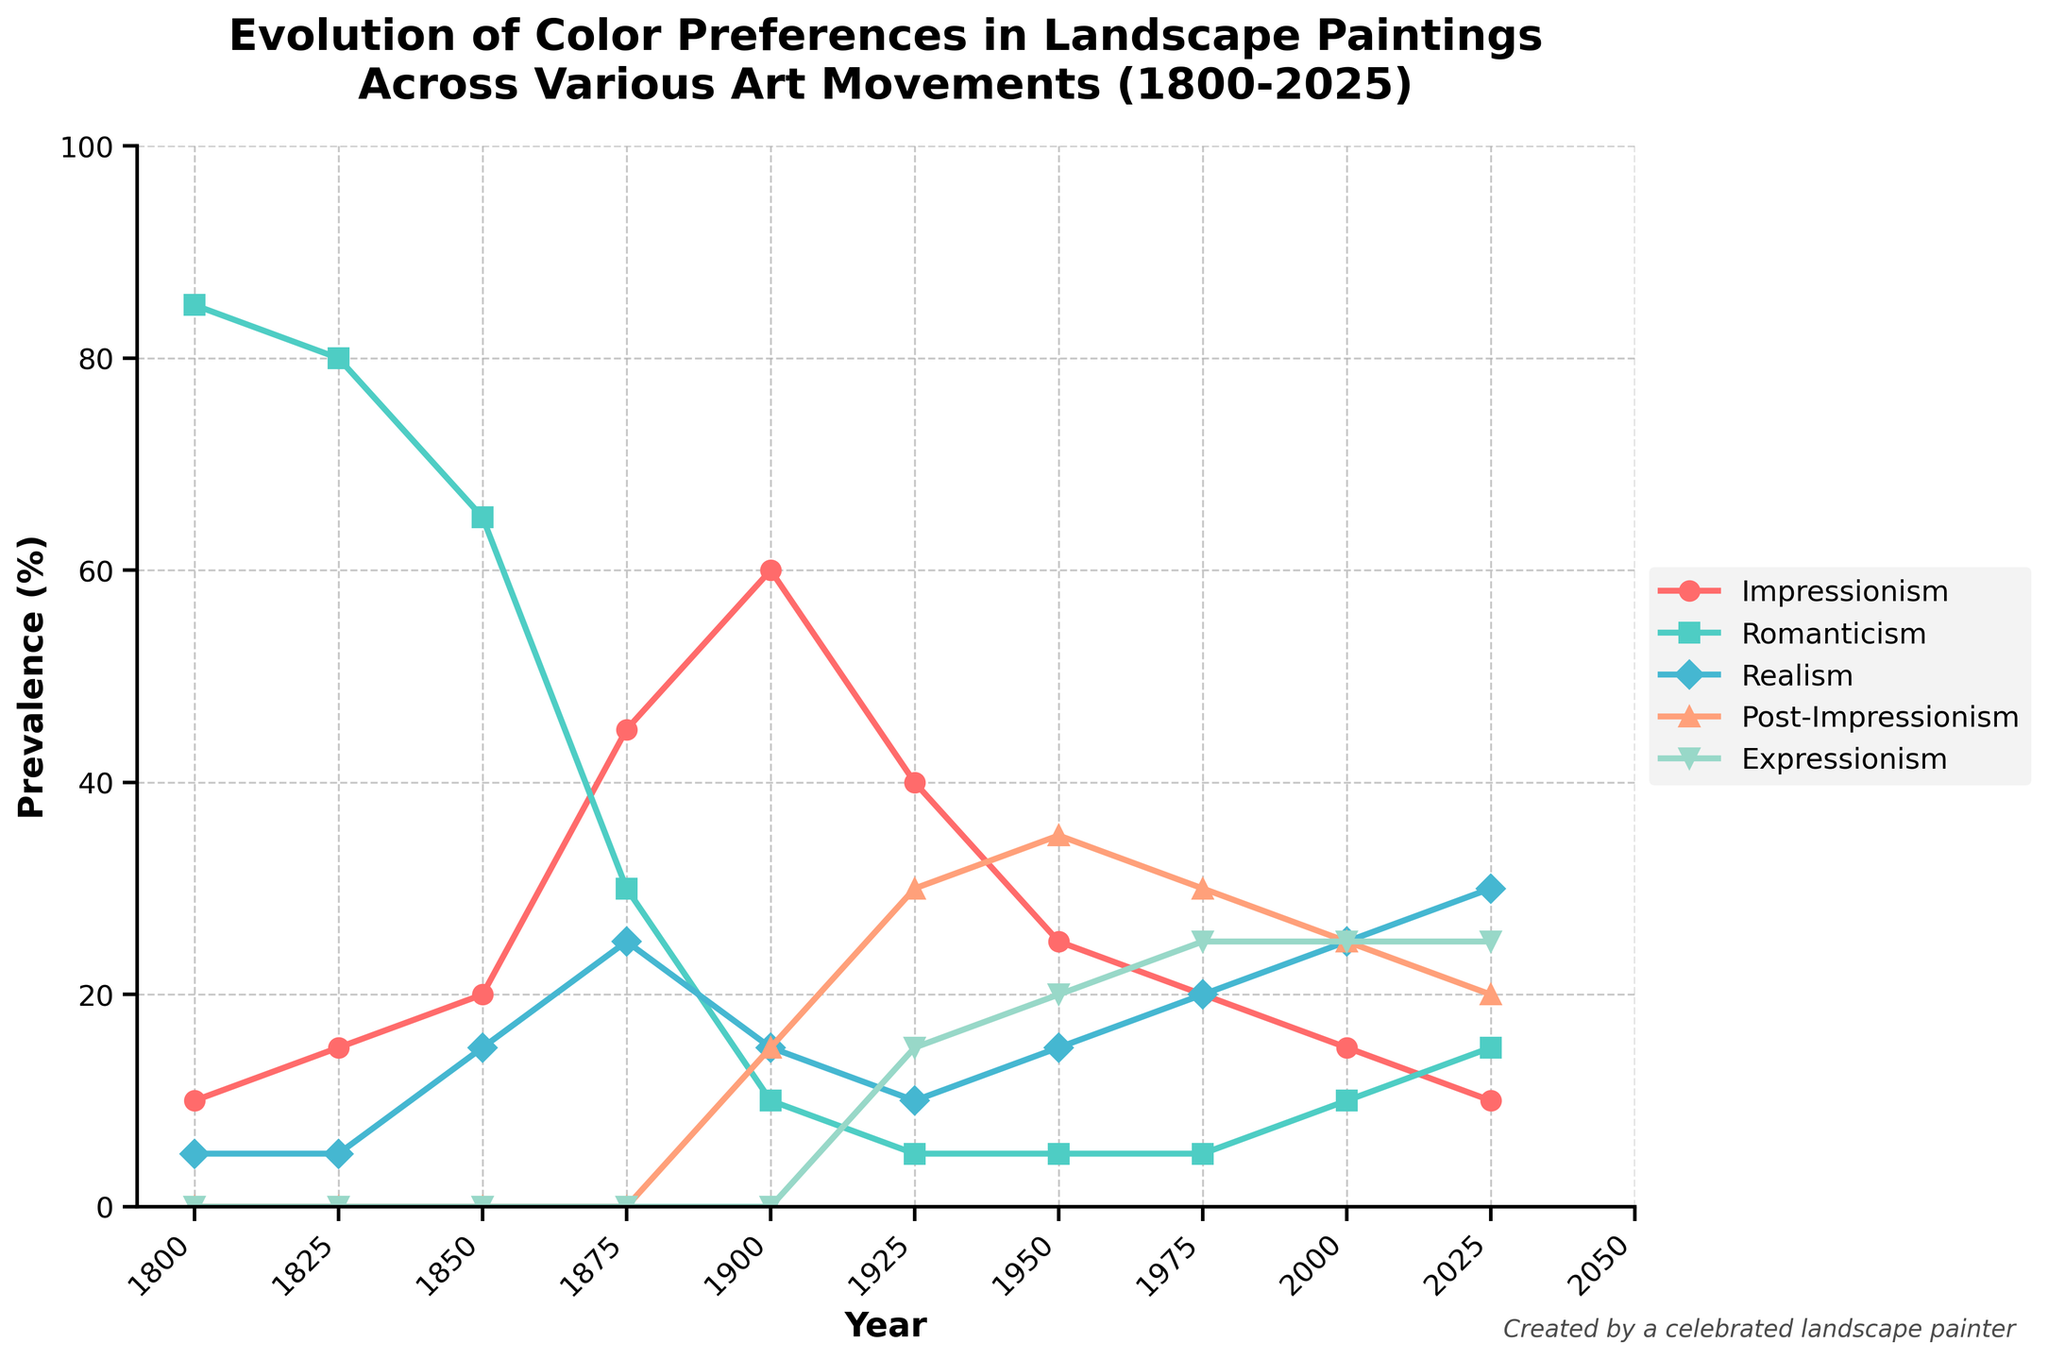What is the title of the chart? The title is prominently displayed at the top of the chart and reads "Evolution of Color Preferences in Landscape Paintings Across Various Art Movements (1800-2025)."
Answer: Evolution of Color Preferences in Landscape Paintings Across Various Art Movements (1800-2025) How many art movements are tracked in this chart? Each line in the chart represents a different art movement, and there are five lines, suggesting five different art movements are tracked.
Answer: Five In what year did Impressionism and Romanticism have equal prevalence? By examining the lines representing Impressionism and Romanticism, we see they intersect in 1925.
Answer: 1925 Which art movement had the highest prevalence in the year 1800? The y-axis values for the year 1800 show that Romanticism has the highest prevalence with a value of 85.
Answer: Romanticism What was the general trend for Romanticism from 1800 to 2025? Looking at the Romanticism line, we see it starts high at 85%, declines steadily until 1900, and then remains low and fairly stable around 5-15%.
Answer: Declining How has the prevalence of Realism changed between 1950 and 2025? The Realism line starts at 15 in 1950 and increases to 30 in 2025.
Answer: Increased from 15 to 30 What is the sum of the prevalence percentages of all art movements in the year 2000? For the year 2000, add the values for all movements: 15 (Impressionism) + 10 (Romanticism) + 25 (Realism) + 25 (Post-Impressionism) + 25 (Expressionism) = 100.
Answer: 100 Which art movement shows the most variability in prevalence over the years? By observing which line fluctuates the most, we see Post-Impressionism varies significantly from 0 to 35, suggesting high variability.
Answer: Post-Impressionism When did Expressionism first appear according to the chart? Expressionism first appears on the chart with a non-zero prevalence in 1925.
Answer: 1925 Between 1900 and 1950, which trend is seen in Impressionism, and what might be implied? Impressionism's prevalence decreases from 60 in 1900 to 25 in 1950, indicating a decline in preference over this time period.
Answer: Declining trend 